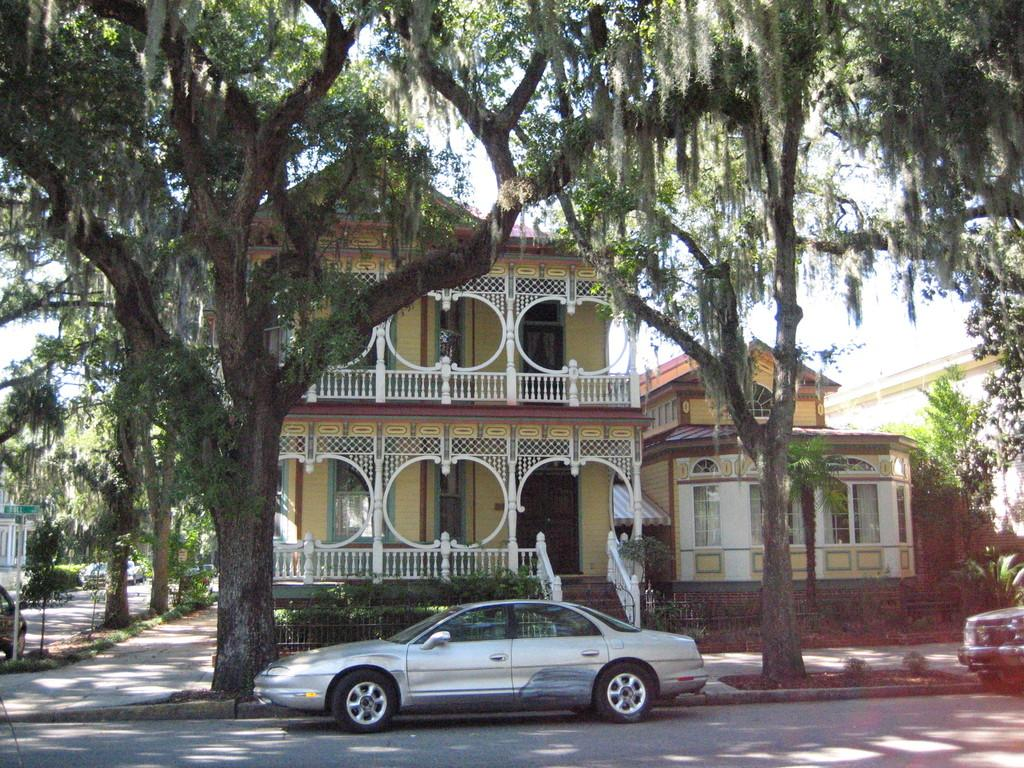How many vehicles can be seen on the road in the image? There are two vehicles on the road in the image. What else can be seen in the image besides the vehicles? There are two trees, buildings, other vehicles, and additional trees in the image. Where is the building located in the image? There is a building in the left corner of the image. What type of comb is being used to groom the pets in the image? There are no pets or combs present in the image. 